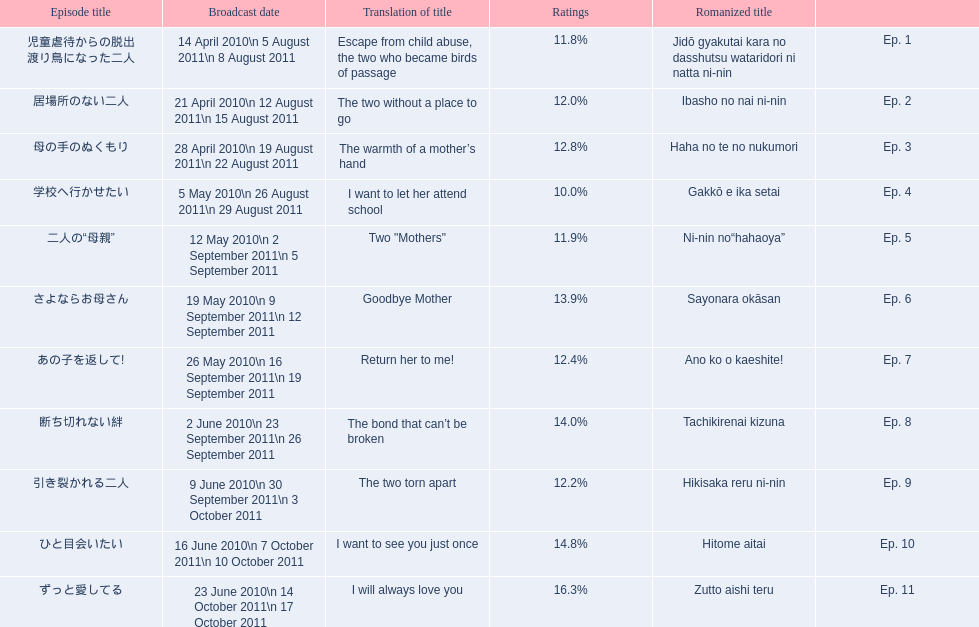How many total episodes are there? Ep. 1, Ep. 2, Ep. 3, Ep. 4, Ep. 5, Ep. 6, Ep. 7, Ep. 8, Ep. 9, Ep. 10, Ep. 11. Of those episodes, which one has the title of the bond that can't be broken? Ep. 8. What was the ratings percentage for that episode? 14.0%. 